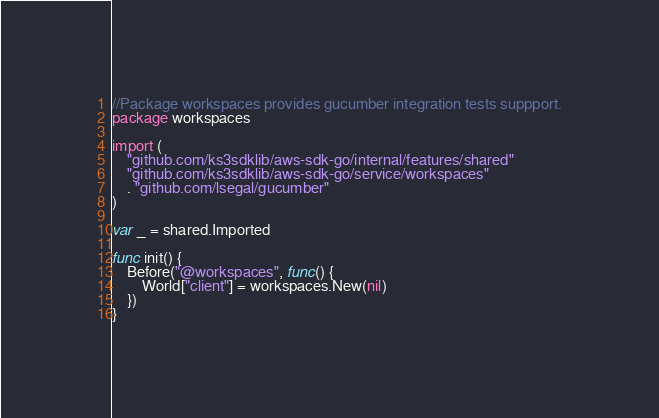Convert code to text. <code><loc_0><loc_0><loc_500><loc_500><_Go_>//Package workspaces provides gucumber integration tests suppport.
package workspaces

import (
	"github.com/ks3sdklib/aws-sdk-go/internal/features/shared"
	"github.com/ks3sdklib/aws-sdk-go/service/workspaces"
	. "github.com/lsegal/gucumber"
)

var _ = shared.Imported

func init() {
	Before("@workspaces", func() {
		World["client"] = workspaces.New(nil)
	})
}
</code> 